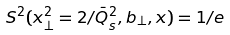Convert formula to latex. <formula><loc_0><loc_0><loc_500><loc_500>S ^ { 2 } ( x _ { \perp } ^ { 2 } = 2 / \bar { Q } _ { s } ^ { 2 } , b _ { \perp } , x ) = 1 / e</formula> 